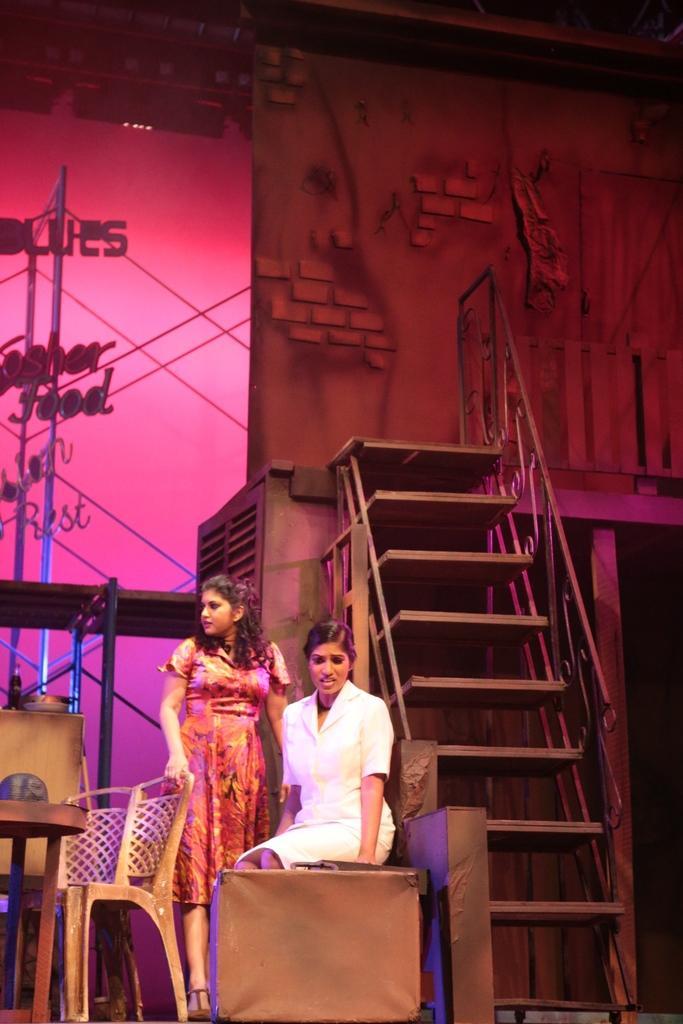Please provide a concise description of this image. In this picture we can see two women, one is seated on the chair and one is standing, in front of them we can find a chair and table, in the background we can see a staircase, wall and couple of lights. 